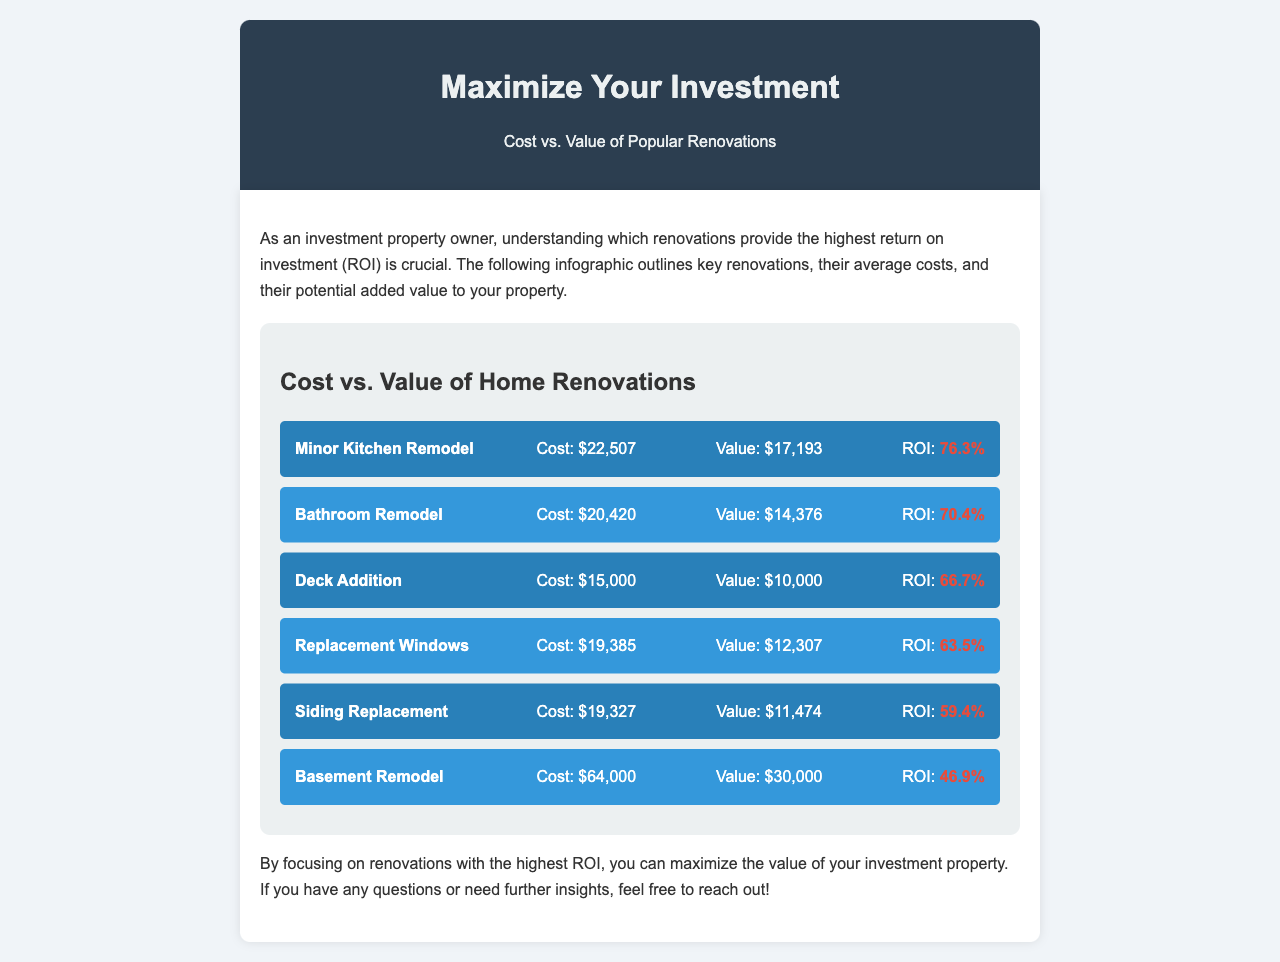What is the cost of a Minor Kitchen Remodel? The document states that the cost of a Minor Kitchen Remodel is $22,507.
Answer: $22,507 What is the ROI of a Bathroom Remodel? The ROI for a Bathroom Remodel is listed as 70.4% in the infographic.
Answer: 70.4% Which renovation has the highest ROI? The Minor Kitchen Remodel has the highest ROI at 76.3%, according to the comparison.
Answer: 76.3% What is the value added by a Deck Addition? The value added by a Deck Addition is $10,000 as per the document.
Answer: $10,000 How much does a Basement Remodel cost? The document specifies that a Basement Remodel costs $64,000.
Answer: $64,000 Which renovation has the lowest ROI? The Basement Remodel has the lowest ROI at 46.9%, according to the infographic.
Answer: 46.9% What are two types of renovations compared in the infographic? The infographic compares renovations such as Minor Kitchen Remodel and Bathroom Remodel.
Answer: Minor Kitchen Remodel and Bathroom Remodel What conclusion does the document provide regarding renovations? The conclusion stresses focusing on renovations with the highest ROI to maximize investment property value.
Answer: Highest ROI 